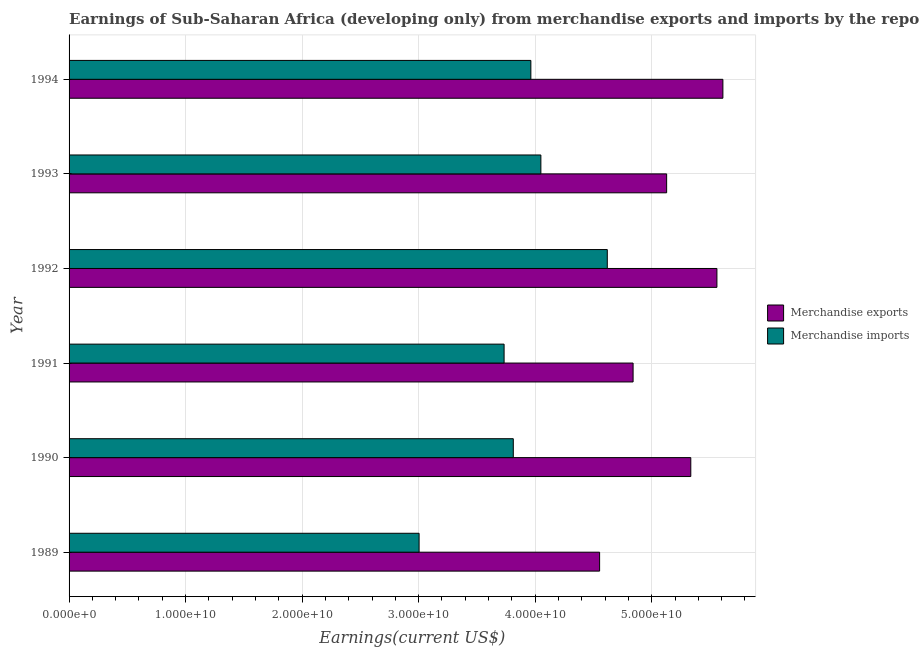Are the number of bars on each tick of the Y-axis equal?
Your answer should be very brief. Yes. How many bars are there on the 6th tick from the bottom?
Ensure brevity in your answer.  2. What is the earnings from merchandise imports in 1994?
Offer a terse response. 3.96e+1. Across all years, what is the maximum earnings from merchandise exports?
Provide a succinct answer. 5.61e+1. Across all years, what is the minimum earnings from merchandise exports?
Provide a succinct answer. 4.55e+1. In which year was the earnings from merchandise imports maximum?
Give a very brief answer. 1992. In which year was the earnings from merchandise exports minimum?
Give a very brief answer. 1989. What is the total earnings from merchandise imports in the graph?
Your response must be concise. 2.32e+11. What is the difference between the earnings from merchandise imports in 1990 and that in 1994?
Offer a very short reply. -1.51e+09. What is the difference between the earnings from merchandise imports in 1989 and the earnings from merchandise exports in 1993?
Keep it short and to the point. -2.12e+1. What is the average earnings from merchandise imports per year?
Give a very brief answer. 3.86e+1. In the year 1994, what is the difference between the earnings from merchandise imports and earnings from merchandise exports?
Your answer should be very brief. -1.65e+1. What is the ratio of the earnings from merchandise imports in 1992 to that in 1994?
Your response must be concise. 1.17. Is the earnings from merchandise exports in 1992 less than that in 1994?
Your answer should be very brief. Yes. What is the difference between the highest and the second highest earnings from merchandise imports?
Offer a very short reply. 5.70e+09. What is the difference between the highest and the lowest earnings from merchandise imports?
Provide a succinct answer. 1.62e+1. In how many years, is the earnings from merchandise exports greater than the average earnings from merchandise exports taken over all years?
Offer a very short reply. 3. How many bars are there?
Make the answer very short. 12. How many years are there in the graph?
Ensure brevity in your answer.  6. What is the difference between two consecutive major ticks on the X-axis?
Your answer should be compact. 1.00e+1. Are the values on the major ticks of X-axis written in scientific E-notation?
Provide a succinct answer. Yes. Does the graph contain grids?
Make the answer very short. Yes. Where does the legend appear in the graph?
Offer a terse response. Center right. What is the title of the graph?
Provide a short and direct response. Earnings of Sub-Saharan Africa (developing only) from merchandise exports and imports by the reporting economy. Does "Rural Population" appear as one of the legend labels in the graph?
Ensure brevity in your answer.  No. What is the label or title of the X-axis?
Your response must be concise. Earnings(current US$). What is the label or title of the Y-axis?
Provide a short and direct response. Year. What is the Earnings(current US$) in Merchandise exports in 1989?
Your response must be concise. 4.55e+1. What is the Earnings(current US$) of Merchandise imports in 1989?
Make the answer very short. 3.00e+1. What is the Earnings(current US$) in Merchandise exports in 1990?
Your response must be concise. 5.34e+1. What is the Earnings(current US$) of Merchandise imports in 1990?
Provide a succinct answer. 3.81e+1. What is the Earnings(current US$) of Merchandise exports in 1991?
Make the answer very short. 4.84e+1. What is the Earnings(current US$) of Merchandise imports in 1991?
Give a very brief answer. 3.73e+1. What is the Earnings(current US$) of Merchandise exports in 1992?
Your answer should be very brief. 5.56e+1. What is the Earnings(current US$) in Merchandise imports in 1992?
Keep it short and to the point. 4.62e+1. What is the Earnings(current US$) in Merchandise exports in 1993?
Provide a short and direct response. 5.13e+1. What is the Earnings(current US$) in Merchandise imports in 1993?
Provide a succinct answer. 4.05e+1. What is the Earnings(current US$) of Merchandise exports in 1994?
Your response must be concise. 5.61e+1. What is the Earnings(current US$) of Merchandise imports in 1994?
Provide a short and direct response. 3.96e+1. Across all years, what is the maximum Earnings(current US$) in Merchandise exports?
Ensure brevity in your answer.  5.61e+1. Across all years, what is the maximum Earnings(current US$) in Merchandise imports?
Ensure brevity in your answer.  4.62e+1. Across all years, what is the minimum Earnings(current US$) of Merchandise exports?
Provide a succinct answer. 4.55e+1. Across all years, what is the minimum Earnings(current US$) of Merchandise imports?
Ensure brevity in your answer.  3.00e+1. What is the total Earnings(current US$) in Merchandise exports in the graph?
Ensure brevity in your answer.  3.10e+11. What is the total Earnings(current US$) in Merchandise imports in the graph?
Your answer should be very brief. 2.32e+11. What is the difference between the Earnings(current US$) in Merchandise exports in 1989 and that in 1990?
Make the answer very short. -7.83e+09. What is the difference between the Earnings(current US$) of Merchandise imports in 1989 and that in 1990?
Provide a short and direct response. -8.08e+09. What is the difference between the Earnings(current US$) in Merchandise exports in 1989 and that in 1991?
Your response must be concise. -2.87e+09. What is the difference between the Earnings(current US$) in Merchandise imports in 1989 and that in 1991?
Your answer should be compact. -7.29e+09. What is the difference between the Earnings(current US$) of Merchandise exports in 1989 and that in 1992?
Make the answer very short. -1.01e+1. What is the difference between the Earnings(current US$) of Merchandise imports in 1989 and that in 1992?
Your answer should be very brief. -1.62e+1. What is the difference between the Earnings(current US$) of Merchandise exports in 1989 and that in 1993?
Ensure brevity in your answer.  -5.75e+09. What is the difference between the Earnings(current US$) in Merchandise imports in 1989 and that in 1993?
Offer a terse response. -1.05e+1. What is the difference between the Earnings(current US$) of Merchandise exports in 1989 and that in 1994?
Give a very brief answer. -1.06e+1. What is the difference between the Earnings(current US$) of Merchandise imports in 1989 and that in 1994?
Make the answer very short. -9.59e+09. What is the difference between the Earnings(current US$) of Merchandise exports in 1990 and that in 1991?
Make the answer very short. 4.95e+09. What is the difference between the Earnings(current US$) in Merchandise imports in 1990 and that in 1991?
Give a very brief answer. 7.90e+08. What is the difference between the Earnings(current US$) of Merchandise exports in 1990 and that in 1992?
Your response must be concise. -2.24e+09. What is the difference between the Earnings(current US$) of Merchandise imports in 1990 and that in 1992?
Provide a succinct answer. -8.07e+09. What is the difference between the Earnings(current US$) of Merchandise exports in 1990 and that in 1993?
Provide a succinct answer. 2.07e+09. What is the difference between the Earnings(current US$) of Merchandise imports in 1990 and that in 1993?
Your response must be concise. -2.37e+09. What is the difference between the Earnings(current US$) in Merchandise exports in 1990 and that in 1994?
Give a very brief answer. -2.76e+09. What is the difference between the Earnings(current US$) in Merchandise imports in 1990 and that in 1994?
Your response must be concise. -1.51e+09. What is the difference between the Earnings(current US$) in Merchandise exports in 1991 and that in 1992?
Provide a succinct answer. -7.19e+09. What is the difference between the Earnings(current US$) of Merchandise imports in 1991 and that in 1992?
Provide a succinct answer. -8.86e+09. What is the difference between the Earnings(current US$) of Merchandise exports in 1991 and that in 1993?
Keep it short and to the point. -2.88e+09. What is the difference between the Earnings(current US$) of Merchandise imports in 1991 and that in 1993?
Make the answer very short. -3.16e+09. What is the difference between the Earnings(current US$) in Merchandise exports in 1991 and that in 1994?
Offer a very short reply. -7.71e+09. What is the difference between the Earnings(current US$) in Merchandise imports in 1991 and that in 1994?
Give a very brief answer. -2.30e+09. What is the difference between the Earnings(current US$) in Merchandise exports in 1992 and that in 1993?
Give a very brief answer. 4.31e+09. What is the difference between the Earnings(current US$) of Merchandise imports in 1992 and that in 1993?
Your answer should be compact. 5.70e+09. What is the difference between the Earnings(current US$) of Merchandise exports in 1992 and that in 1994?
Offer a terse response. -5.13e+08. What is the difference between the Earnings(current US$) in Merchandise imports in 1992 and that in 1994?
Your answer should be very brief. 6.56e+09. What is the difference between the Earnings(current US$) of Merchandise exports in 1993 and that in 1994?
Ensure brevity in your answer.  -4.83e+09. What is the difference between the Earnings(current US$) in Merchandise imports in 1993 and that in 1994?
Your answer should be very brief. 8.59e+08. What is the difference between the Earnings(current US$) of Merchandise exports in 1989 and the Earnings(current US$) of Merchandise imports in 1990?
Your answer should be very brief. 7.41e+09. What is the difference between the Earnings(current US$) in Merchandise exports in 1989 and the Earnings(current US$) in Merchandise imports in 1991?
Give a very brief answer. 8.20e+09. What is the difference between the Earnings(current US$) of Merchandise exports in 1989 and the Earnings(current US$) of Merchandise imports in 1992?
Give a very brief answer. -6.60e+08. What is the difference between the Earnings(current US$) of Merchandise exports in 1989 and the Earnings(current US$) of Merchandise imports in 1993?
Your response must be concise. 5.04e+09. What is the difference between the Earnings(current US$) in Merchandise exports in 1989 and the Earnings(current US$) in Merchandise imports in 1994?
Provide a short and direct response. 5.90e+09. What is the difference between the Earnings(current US$) in Merchandise exports in 1990 and the Earnings(current US$) in Merchandise imports in 1991?
Make the answer very short. 1.60e+1. What is the difference between the Earnings(current US$) of Merchandise exports in 1990 and the Earnings(current US$) of Merchandise imports in 1992?
Your answer should be very brief. 7.17e+09. What is the difference between the Earnings(current US$) of Merchandise exports in 1990 and the Earnings(current US$) of Merchandise imports in 1993?
Provide a short and direct response. 1.29e+1. What is the difference between the Earnings(current US$) in Merchandise exports in 1990 and the Earnings(current US$) in Merchandise imports in 1994?
Provide a short and direct response. 1.37e+1. What is the difference between the Earnings(current US$) of Merchandise exports in 1991 and the Earnings(current US$) of Merchandise imports in 1992?
Provide a short and direct response. 2.21e+09. What is the difference between the Earnings(current US$) in Merchandise exports in 1991 and the Earnings(current US$) in Merchandise imports in 1993?
Offer a terse response. 7.91e+09. What is the difference between the Earnings(current US$) of Merchandise exports in 1991 and the Earnings(current US$) of Merchandise imports in 1994?
Your answer should be very brief. 8.77e+09. What is the difference between the Earnings(current US$) in Merchandise exports in 1992 and the Earnings(current US$) in Merchandise imports in 1993?
Offer a terse response. 1.51e+1. What is the difference between the Earnings(current US$) in Merchandise exports in 1992 and the Earnings(current US$) in Merchandise imports in 1994?
Offer a terse response. 1.60e+1. What is the difference between the Earnings(current US$) of Merchandise exports in 1993 and the Earnings(current US$) of Merchandise imports in 1994?
Offer a terse response. 1.17e+1. What is the average Earnings(current US$) of Merchandise exports per year?
Ensure brevity in your answer.  5.17e+1. What is the average Earnings(current US$) of Merchandise imports per year?
Ensure brevity in your answer.  3.86e+1. In the year 1989, what is the difference between the Earnings(current US$) in Merchandise exports and Earnings(current US$) in Merchandise imports?
Provide a short and direct response. 1.55e+1. In the year 1990, what is the difference between the Earnings(current US$) of Merchandise exports and Earnings(current US$) of Merchandise imports?
Provide a short and direct response. 1.52e+1. In the year 1991, what is the difference between the Earnings(current US$) in Merchandise exports and Earnings(current US$) in Merchandise imports?
Offer a terse response. 1.11e+1. In the year 1992, what is the difference between the Earnings(current US$) in Merchandise exports and Earnings(current US$) in Merchandise imports?
Provide a succinct answer. 9.41e+09. In the year 1993, what is the difference between the Earnings(current US$) in Merchandise exports and Earnings(current US$) in Merchandise imports?
Provide a succinct answer. 1.08e+1. In the year 1994, what is the difference between the Earnings(current US$) of Merchandise exports and Earnings(current US$) of Merchandise imports?
Offer a very short reply. 1.65e+1. What is the ratio of the Earnings(current US$) in Merchandise exports in 1989 to that in 1990?
Make the answer very short. 0.85. What is the ratio of the Earnings(current US$) of Merchandise imports in 1989 to that in 1990?
Offer a very short reply. 0.79. What is the ratio of the Earnings(current US$) of Merchandise exports in 1989 to that in 1991?
Your response must be concise. 0.94. What is the ratio of the Earnings(current US$) in Merchandise imports in 1989 to that in 1991?
Offer a very short reply. 0.8. What is the ratio of the Earnings(current US$) of Merchandise exports in 1989 to that in 1992?
Your answer should be very brief. 0.82. What is the ratio of the Earnings(current US$) of Merchandise imports in 1989 to that in 1992?
Your answer should be compact. 0.65. What is the ratio of the Earnings(current US$) of Merchandise exports in 1989 to that in 1993?
Ensure brevity in your answer.  0.89. What is the ratio of the Earnings(current US$) of Merchandise imports in 1989 to that in 1993?
Offer a very short reply. 0.74. What is the ratio of the Earnings(current US$) in Merchandise exports in 1989 to that in 1994?
Provide a short and direct response. 0.81. What is the ratio of the Earnings(current US$) in Merchandise imports in 1989 to that in 1994?
Keep it short and to the point. 0.76. What is the ratio of the Earnings(current US$) of Merchandise exports in 1990 to that in 1991?
Your answer should be compact. 1.1. What is the ratio of the Earnings(current US$) of Merchandise imports in 1990 to that in 1991?
Offer a very short reply. 1.02. What is the ratio of the Earnings(current US$) in Merchandise exports in 1990 to that in 1992?
Offer a very short reply. 0.96. What is the ratio of the Earnings(current US$) in Merchandise imports in 1990 to that in 1992?
Provide a succinct answer. 0.83. What is the ratio of the Earnings(current US$) in Merchandise exports in 1990 to that in 1993?
Make the answer very short. 1.04. What is the ratio of the Earnings(current US$) in Merchandise imports in 1990 to that in 1993?
Keep it short and to the point. 0.94. What is the ratio of the Earnings(current US$) in Merchandise exports in 1990 to that in 1994?
Offer a very short reply. 0.95. What is the ratio of the Earnings(current US$) in Merchandise imports in 1990 to that in 1994?
Offer a terse response. 0.96. What is the ratio of the Earnings(current US$) of Merchandise exports in 1991 to that in 1992?
Provide a short and direct response. 0.87. What is the ratio of the Earnings(current US$) in Merchandise imports in 1991 to that in 1992?
Give a very brief answer. 0.81. What is the ratio of the Earnings(current US$) in Merchandise exports in 1991 to that in 1993?
Keep it short and to the point. 0.94. What is the ratio of the Earnings(current US$) of Merchandise imports in 1991 to that in 1993?
Give a very brief answer. 0.92. What is the ratio of the Earnings(current US$) of Merchandise exports in 1991 to that in 1994?
Your answer should be very brief. 0.86. What is the ratio of the Earnings(current US$) of Merchandise imports in 1991 to that in 1994?
Provide a short and direct response. 0.94. What is the ratio of the Earnings(current US$) of Merchandise exports in 1992 to that in 1993?
Give a very brief answer. 1.08. What is the ratio of the Earnings(current US$) in Merchandise imports in 1992 to that in 1993?
Make the answer very short. 1.14. What is the ratio of the Earnings(current US$) of Merchandise exports in 1992 to that in 1994?
Make the answer very short. 0.99. What is the ratio of the Earnings(current US$) in Merchandise imports in 1992 to that in 1994?
Your response must be concise. 1.17. What is the ratio of the Earnings(current US$) in Merchandise exports in 1993 to that in 1994?
Offer a terse response. 0.91. What is the ratio of the Earnings(current US$) of Merchandise imports in 1993 to that in 1994?
Give a very brief answer. 1.02. What is the difference between the highest and the second highest Earnings(current US$) of Merchandise exports?
Offer a terse response. 5.13e+08. What is the difference between the highest and the second highest Earnings(current US$) of Merchandise imports?
Offer a very short reply. 5.70e+09. What is the difference between the highest and the lowest Earnings(current US$) in Merchandise exports?
Your answer should be compact. 1.06e+1. What is the difference between the highest and the lowest Earnings(current US$) of Merchandise imports?
Provide a succinct answer. 1.62e+1. 